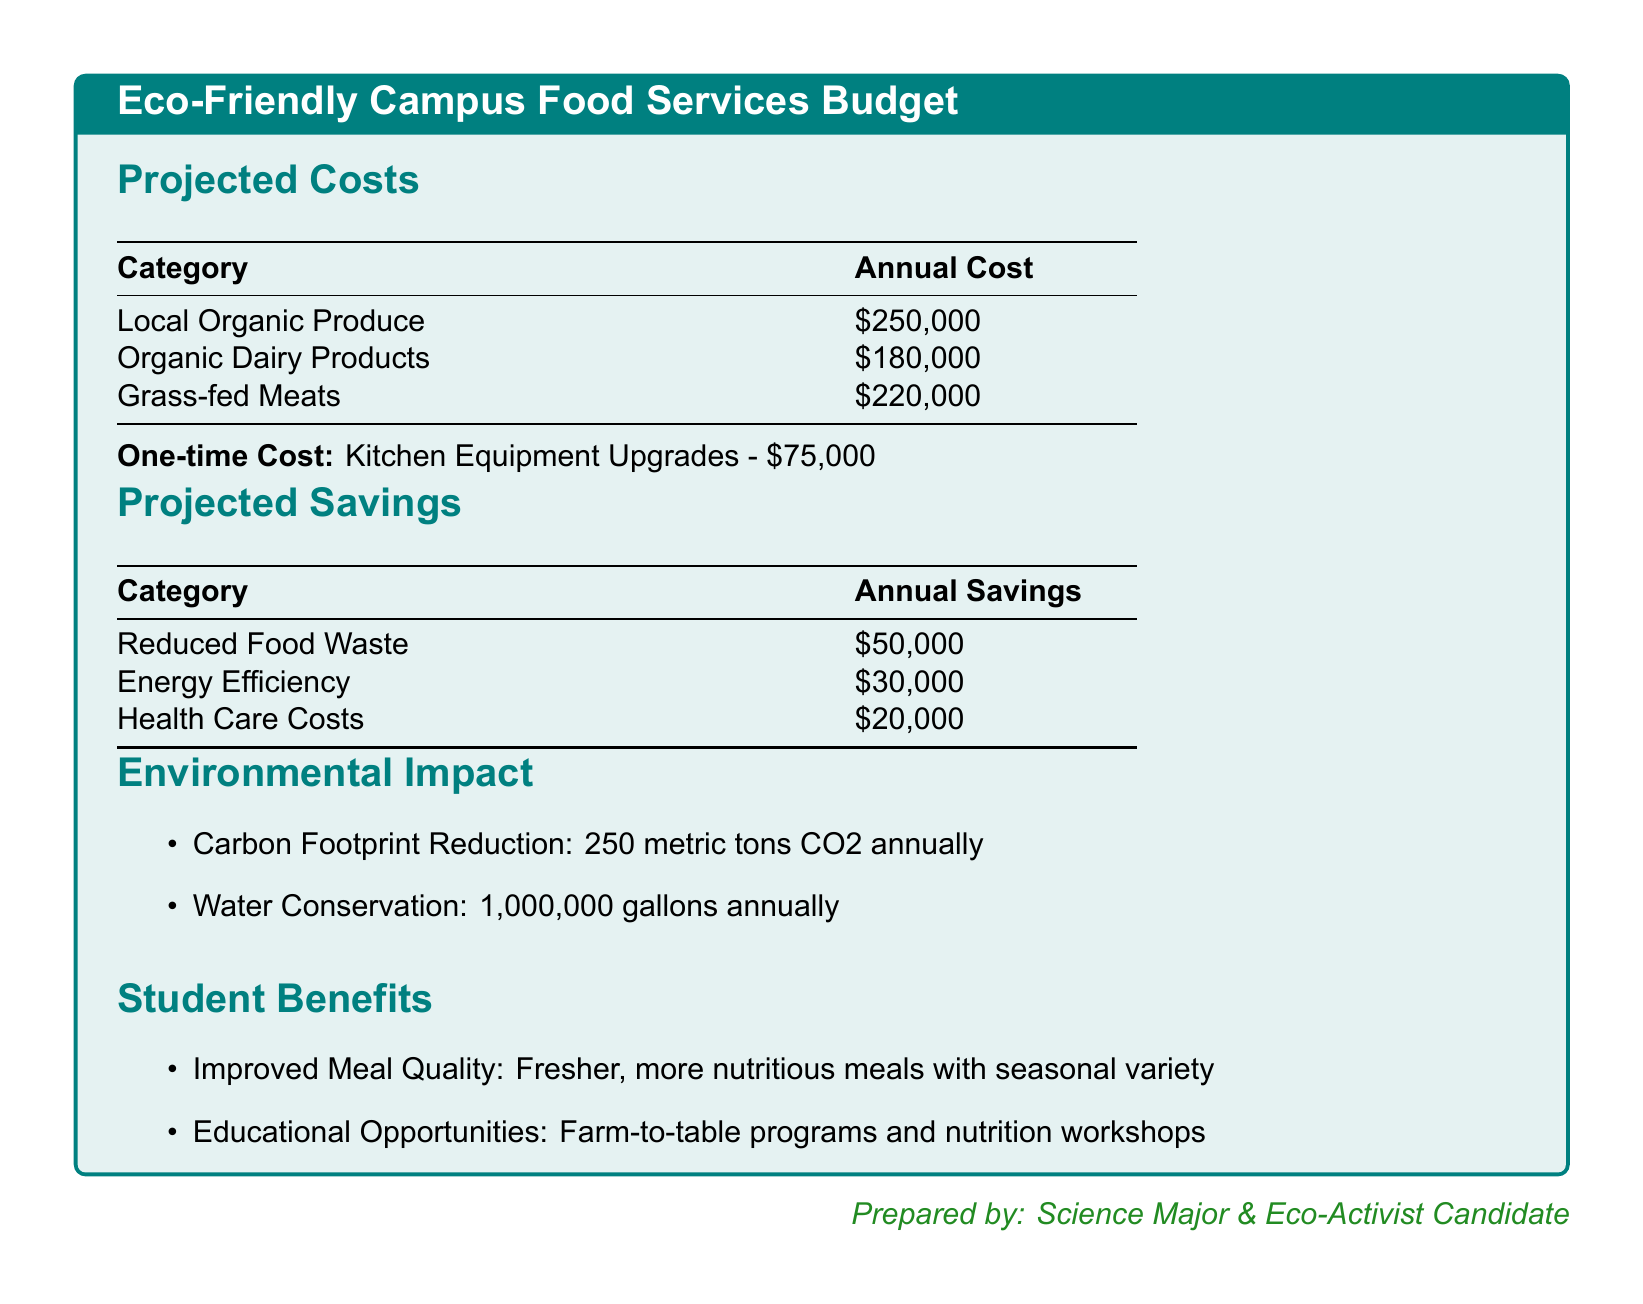What is the total cost of local organic produce? The cost of local organic produce is listed in the projected costs section as $250,000.
Answer: $250,000 What is the one-time cost for kitchen equipment upgrades? The one-time cost for kitchen equipment upgrades is specified in the document as $75,000.
Answer: $75,000 What are the projected annual savings from reduced food waste? The document provides the annual savings from reduced food waste, listed as $50,000.
Answer: $50,000 How much will be saved annually through energy efficiency? The savings from energy efficiency is mentioned in the projected savings section, totaling $30,000.
Answer: $30,000 What is the total annual cost for organic dairy products and grass-fed meats combined? The total annual cost for organic dairy products ($180,000) and grass-fed meats ($220,000) is calculated as $180,000 + $220,000.
Answer: $400,000 How many metric tons of CO2 will be reduced annually? The document states that the carbon footprint reduction will be 250 metric tons CO2 annually.
Answer: 250 metric tons What is the total annual savings expected from health care costs? The expected annual savings from health care costs is given as $20,000 in the projected savings section.
Answer: $20,000 What educational opportunities are mentioned? The document lists farm-to-table programs and nutrition workshops as educational opportunities.
Answer: Farm-to-table programs and nutrition workshops How much water will be conserved annually? The water conservation amount stated in the document is 1,000,000 gallons annually.
Answer: 1,000,000 gallons 